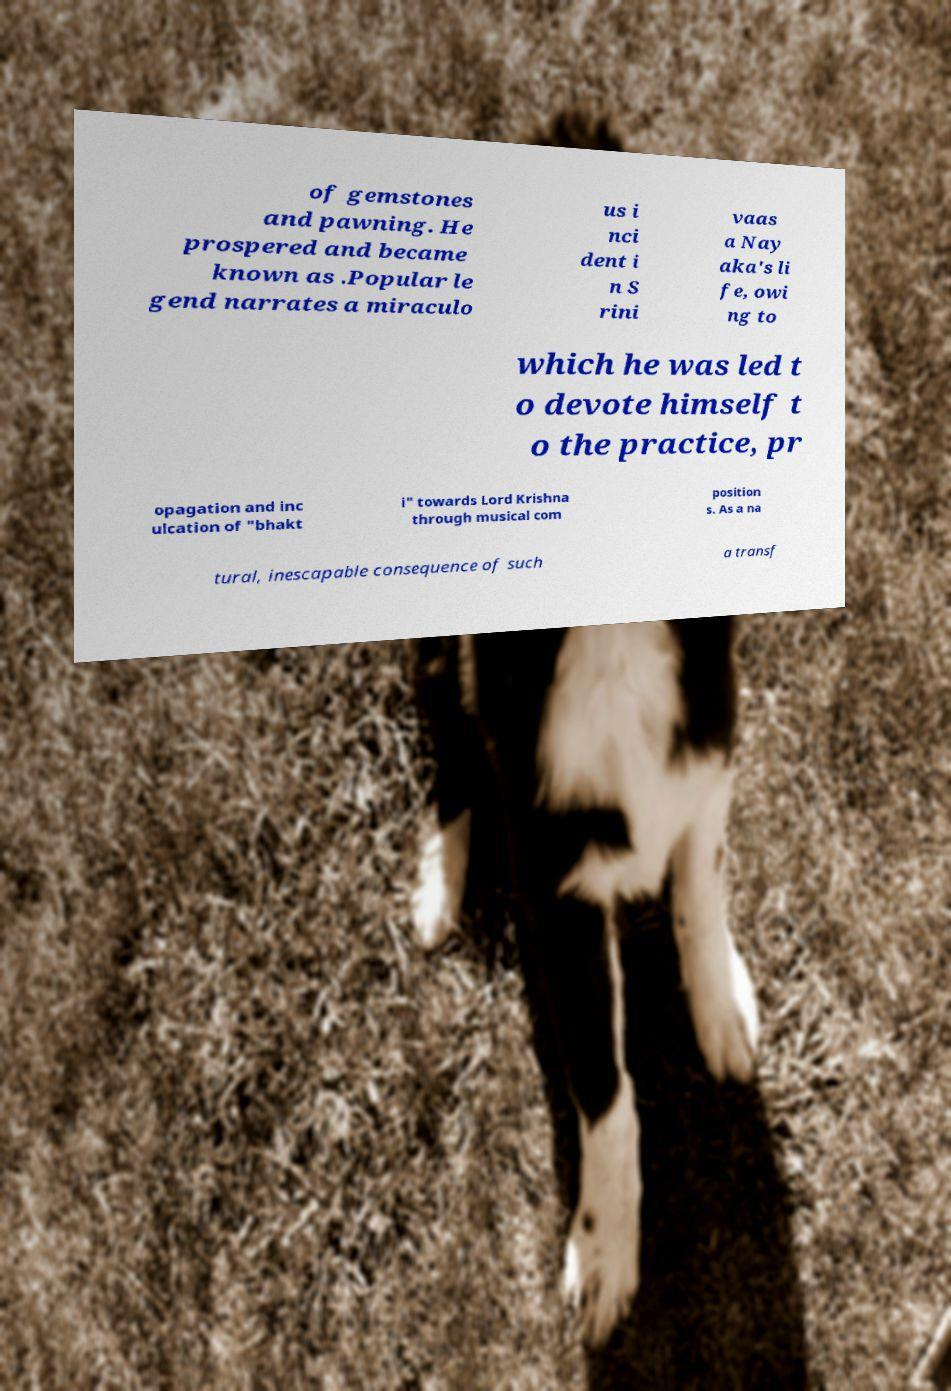Could you extract and type out the text from this image? of gemstones and pawning. He prospered and became known as .Popular le gend narrates a miraculo us i nci dent i n S rini vaas a Nay aka's li fe, owi ng to which he was led t o devote himself t o the practice, pr opagation and inc ulcation of "bhakt i" towards Lord Krishna through musical com position s. As a na tural, inescapable consequence of such a transf 